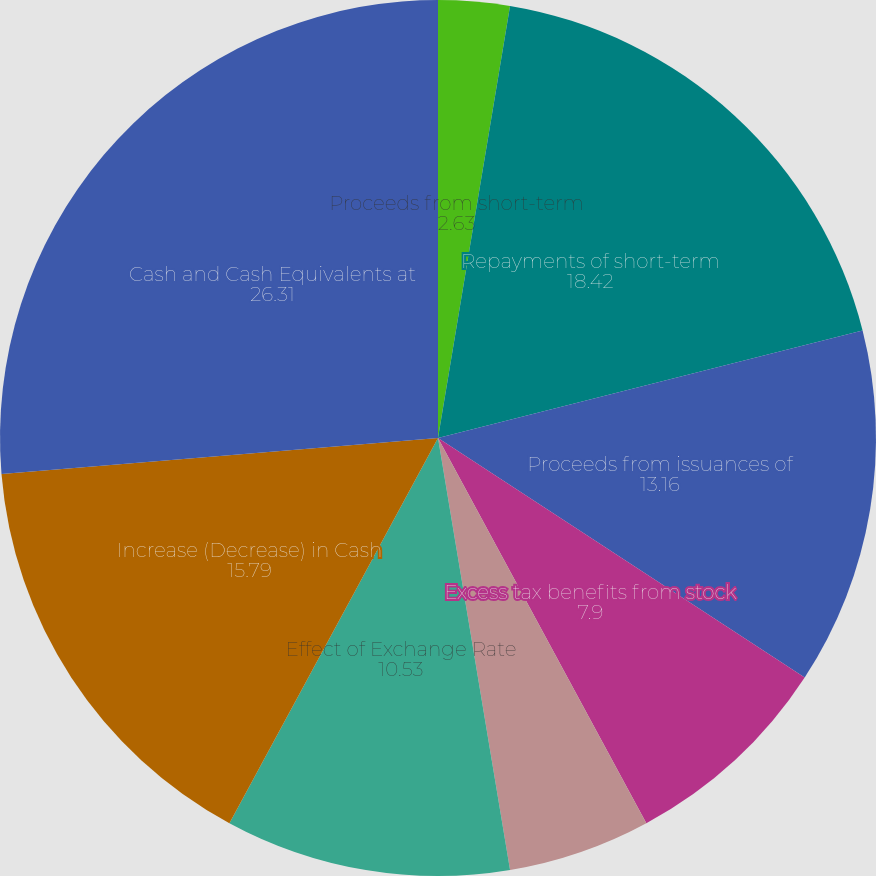Convert chart. <chart><loc_0><loc_0><loc_500><loc_500><pie_chart><fcel>Repayments of long-term<fcel>Proceeds from short-term<fcel>Repayments of short-term<fcel>Proceeds from issuances of<fcel>Excess tax benefits from stock<fcel>Net cash provided by (used<fcel>Effect of Exchange Rate<fcel>Increase (Decrease) in Cash<fcel>Cash and Cash Equivalents at<nl><fcel>0.0%<fcel>2.63%<fcel>18.42%<fcel>13.16%<fcel>7.9%<fcel>5.26%<fcel>10.53%<fcel>15.79%<fcel>26.31%<nl></chart> 